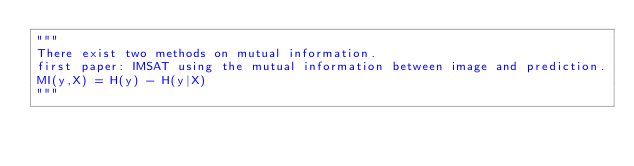Convert code to text. <code><loc_0><loc_0><loc_500><loc_500><_Python_>"""
There exist two methods on mutual information.
first paper: IMSAT using the mutual information between image and prediction.
MI(y,X) = H(y) - H(y|X)
"""
</code> 